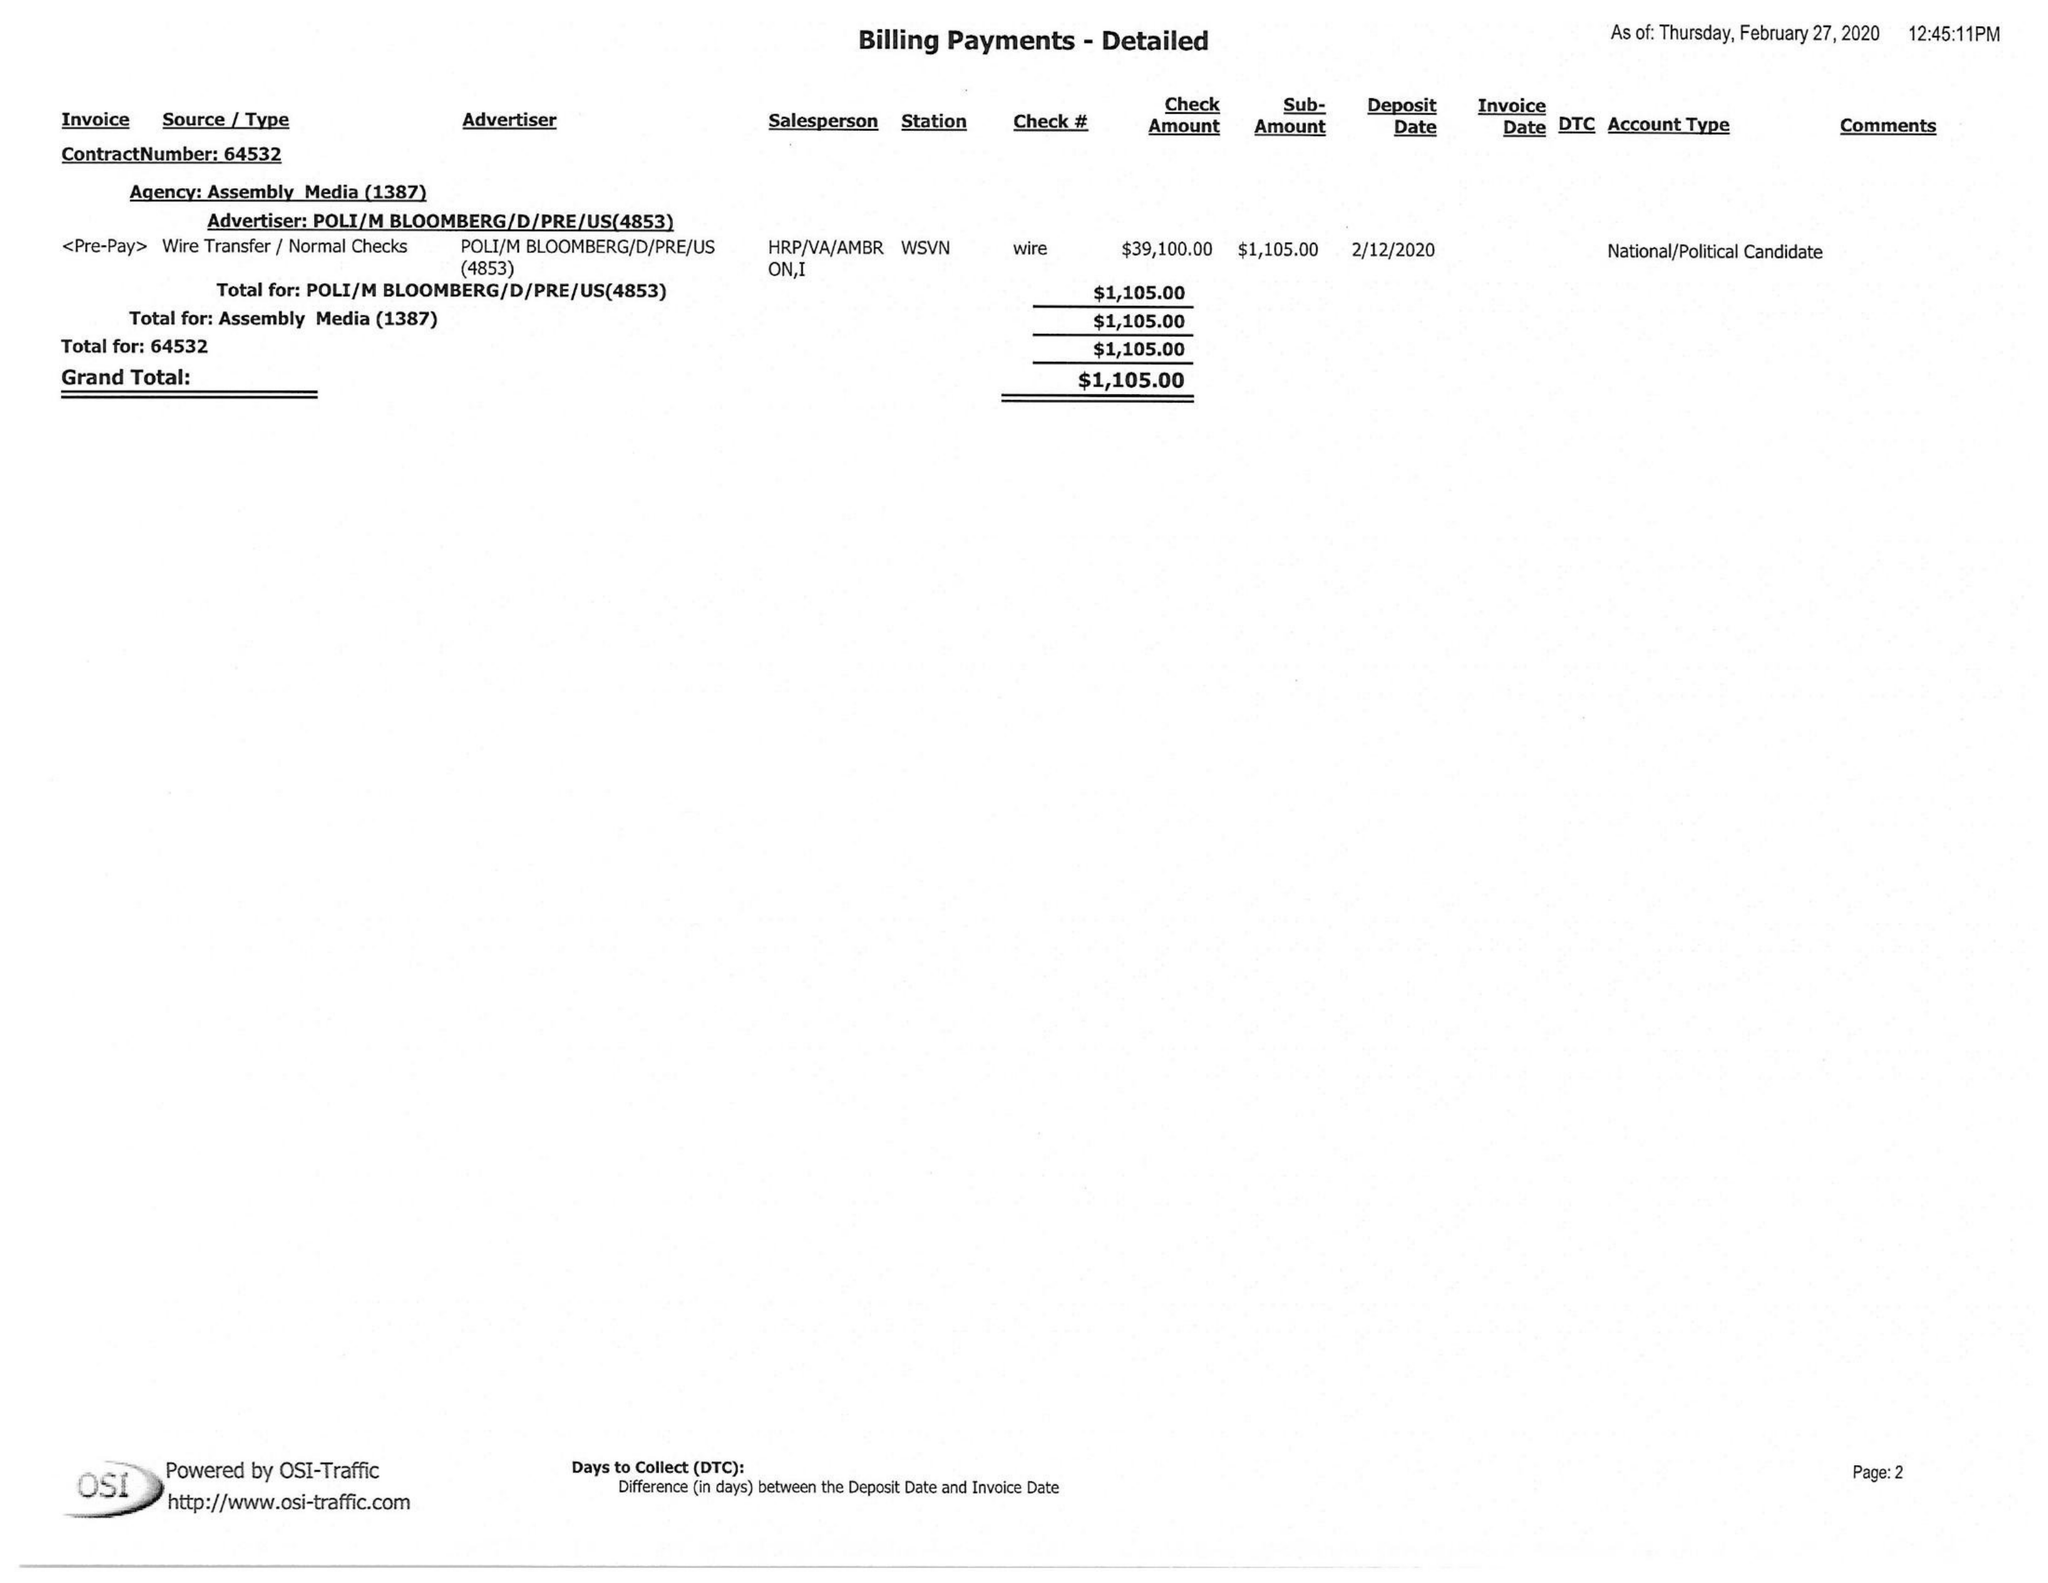What is the value for the advertiser?
Answer the question using a single word or phrase. POLI/MBLOOMBERG/D/PRE/US 